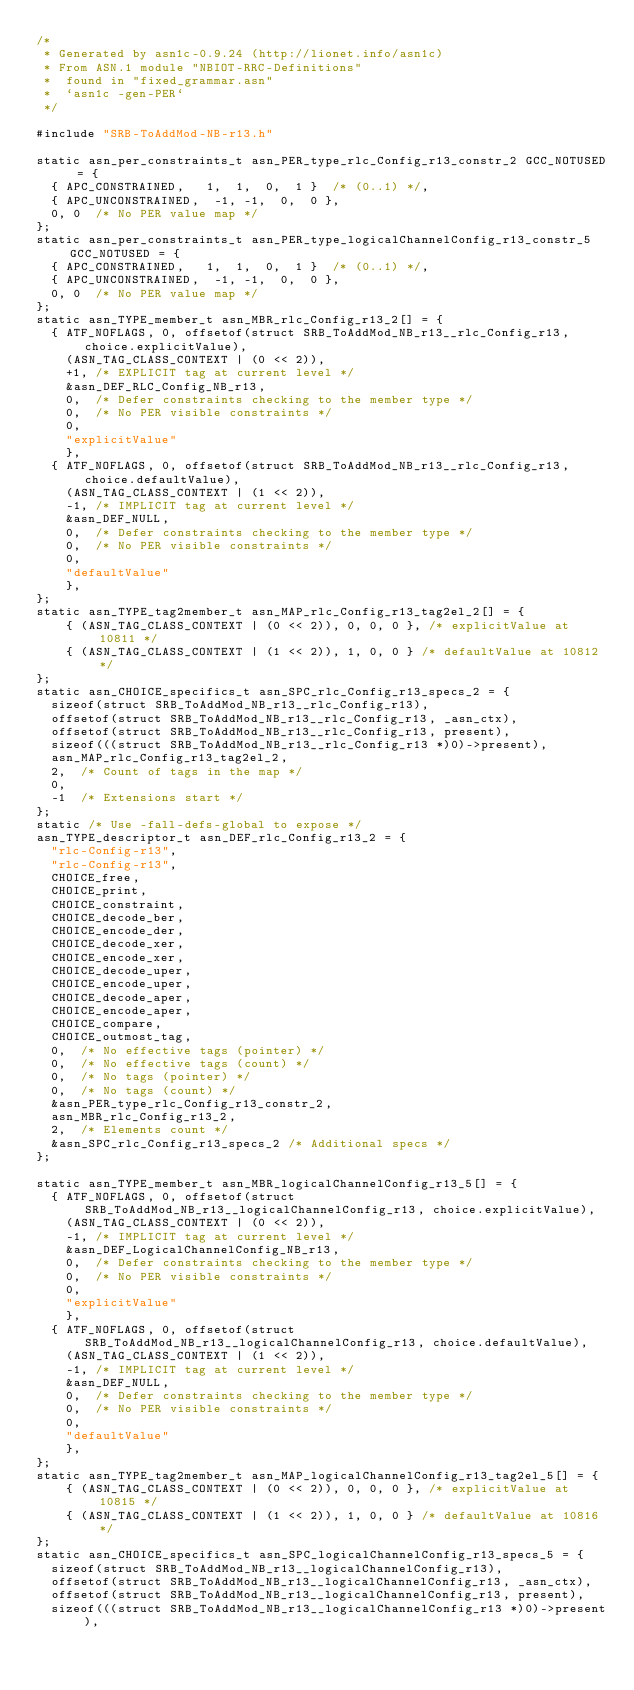<code> <loc_0><loc_0><loc_500><loc_500><_C_>/*
 * Generated by asn1c-0.9.24 (http://lionet.info/asn1c)
 * From ASN.1 module "NBIOT-RRC-Definitions"
 * 	found in "fixed_grammar.asn"
 * 	`asn1c -gen-PER`
 */

#include "SRB-ToAddMod-NB-r13.h"

static asn_per_constraints_t asn_PER_type_rlc_Config_r13_constr_2 GCC_NOTUSED = {
	{ APC_CONSTRAINED,	 1,  1,  0,  1 }	/* (0..1) */,
	{ APC_UNCONSTRAINED,	-1, -1,  0,  0 },
	0, 0	/* No PER value map */
};
static asn_per_constraints_t asn_PER_type_logicalChannelConfig_r13_constr_5 GCC_NOTUSED = {
	{ APC_CONSTRAINED,	 1,  1,  0,  1 }	/* (0..1) */,
	{ APC_UNCONSTRAINED,	-1, -1,  0,  0 },
	0, 0	/* No PER value map */
};
static asn_TYPE_member_t asn_MBR_rlc_Config_r13_2[] = {
	{ ATF_NOFLAGS, 0, offsetof(struct SRB_ToAddMod_NB_r13__rlc_Config_r13, choice.explicitValue),
		(ASN_TAG_CLASS_CONTEXT | (0 << 2)),
		+1,	/* EXPLICIT tag at current level */
		&asn_DEF_RLC_Config_NB_r13,
		0,	/* Defer constraints checking to the member type */
		0,	/* No PER visible constraints */
		0,
		"explicitValue"
		},
	{ ATF_NOFLAGS, 0, offsetof(struct SRB_ToAddMod_NB_r13__rlc_Config_r13, choice.defaultValue),
		(ASN_TAG_CLASS_CONTEXT | (1 << 2)),
		-1,	/* IMPLICIT tag at current level */
		&asn_DEF_NULL,
		0,	/* Defer constraints checking to the member type */
		0,	/* No PER visible constraints */
		0,
		"defaultValue"
		},
};
static asn_TYPE_tag2member_t asn_MAP_rlc_Config_r13_tag2el_2[] = {
    { (ASN_TAG_CLASS_CONTEXT | (0 << 2)), 0, 0, 0 }, /* explicitValue at 10811 */
    { (ASN_TAG_CLASS_CONTEXT | (1 << 2)), 1, 0, 0 } /* defaultValue at 10812 */
};
static asn_CHOICE_specifics_t asn_SPC_rlc_Config_r13_specs_2 = {
	sizeof(struct SRB_ToAddMod_NB_r13__rlc_Config_r13),
	offsetof(struct SRB_ToAddMod_NB_r13__rlc_Config_r13, _asn_ctx),
	offsetof(struct SRB_ToAddMod_NB_r13__rlc_Config_r13, present),
	sizeof(((struct SRB_ToAddMod_NB_r13__rlc_Config_r13 *)0)->present),
	asn_MAP_rlc_Config_r13_tag2el_2,
	2,	/* Count of tags in the map */
	0,
	-1	/* Extensions start */
};
static /* Use -fall-defs-global to expose */
asn_TYPE_descriptor_t asn_DEF_rlc_Config_r13_2 = {
	"rlc-Config-r13",
	"rlc-Config-r13",
	CHOICE_free,
	CHOICE_print,
	CHOICE_constraint,
	CHOICE_decode_ber,
	CHOICE_encode_der,
	CHOICE_decode_xer,
	CHOICE_encode_xer,
	CHOICE_decode_uper,
	CHOICE_encode_uper,
	CHOICE_decode_aper,
	CHOICE_encode_aper,
	CHOICE_compare,
	CHOICE_outmost_tag,
	0,	/* No effective tags (pointer) */
	0,	/* No effective tags (count) */
	0,	/* No tags (pointer) */
	0,	/* No tags (count) */
	&asn_PER_type_rlc_Config_r13_constr_2,
	asn_MBR_rlc_Config_r13_2,
	2,	/* Elements count */
	&asn_SPC_rlc_Config_r13_specs_2	/* Additional specs */
};

static asn_TYPE_member_t asn_MBR_logicalChannelConfig_r13_5[] = {
	{ ATF_NOFLAGS, 0, offsetof(struct SRB_ToAddMod_NB_r13__logicalChannelConfig_r13, choice.explicitValue),
		(ASN_TAG_CLASS_CONTEXT | (0 << 2)),
		-1,	/* IMPLICIT tag at current level */
		&asn_DEF_LogicalChannelConfig_NB_r13,
		0,	/* Defer constraints checking to the member type */
		0,	/* No PER visible constraints */
		0,
		"explicitValue"
		},
	{ ATF_NOFLAGS, 0, offsetof(struct SRB_ToAddMod_NB_r13__logicalChannelConfig_r13, choice.defaultValue),
		(ASN_TAG_CLASS_CONTEXT | (1 << 2)),
		-1,	/* IMPLICIT tag at current level */
		&asn_DEF_NULL,
		0,	/* Defer constraints checking to the member type */
		0,	/* No PER visible constraints */
		0,
		"defaultValue"
		},
};
static asn_TYPE_tag2member_t asn_MAP_logicalChannelConfig_r13_tag2el_5[] = {
    { (ASN_TAG_CLASS_CONTEXT | (0 << 2)), 0, 0, 0 }, /* explicitValue at 10815 */
    { (ASN_TAG_CLASS_CONTEXT | (1 << 2)), 1, 0, 0 } /* defaultValue at 10816 */
};
static asn_CHOICE_specifics_t asn_SPC_logicalChannelConfig_r13_specs_5 = {
	sizeof(struct SRB_ToAddMod_NB_r13__logicalChannelConfig_r13),
	offsetof(struct SRB_ToAddMod_NB_r13__logicalChannelConfig_r13, _asn_ctx),
	offsetof(struct SRB_ToAddMod_NB_r13__logicalChannelConfig_r13, present),
	sizeof(((struct SRB_ToAddMod_NB_r13__logicalChannelConfig_r13 *)0)->present),</code> 